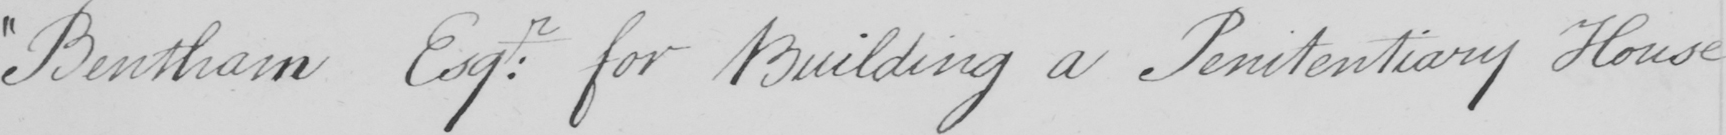Transcribe the text shown in this historical manuscript line. Bentham Esq : r for building a Penitentiary House 